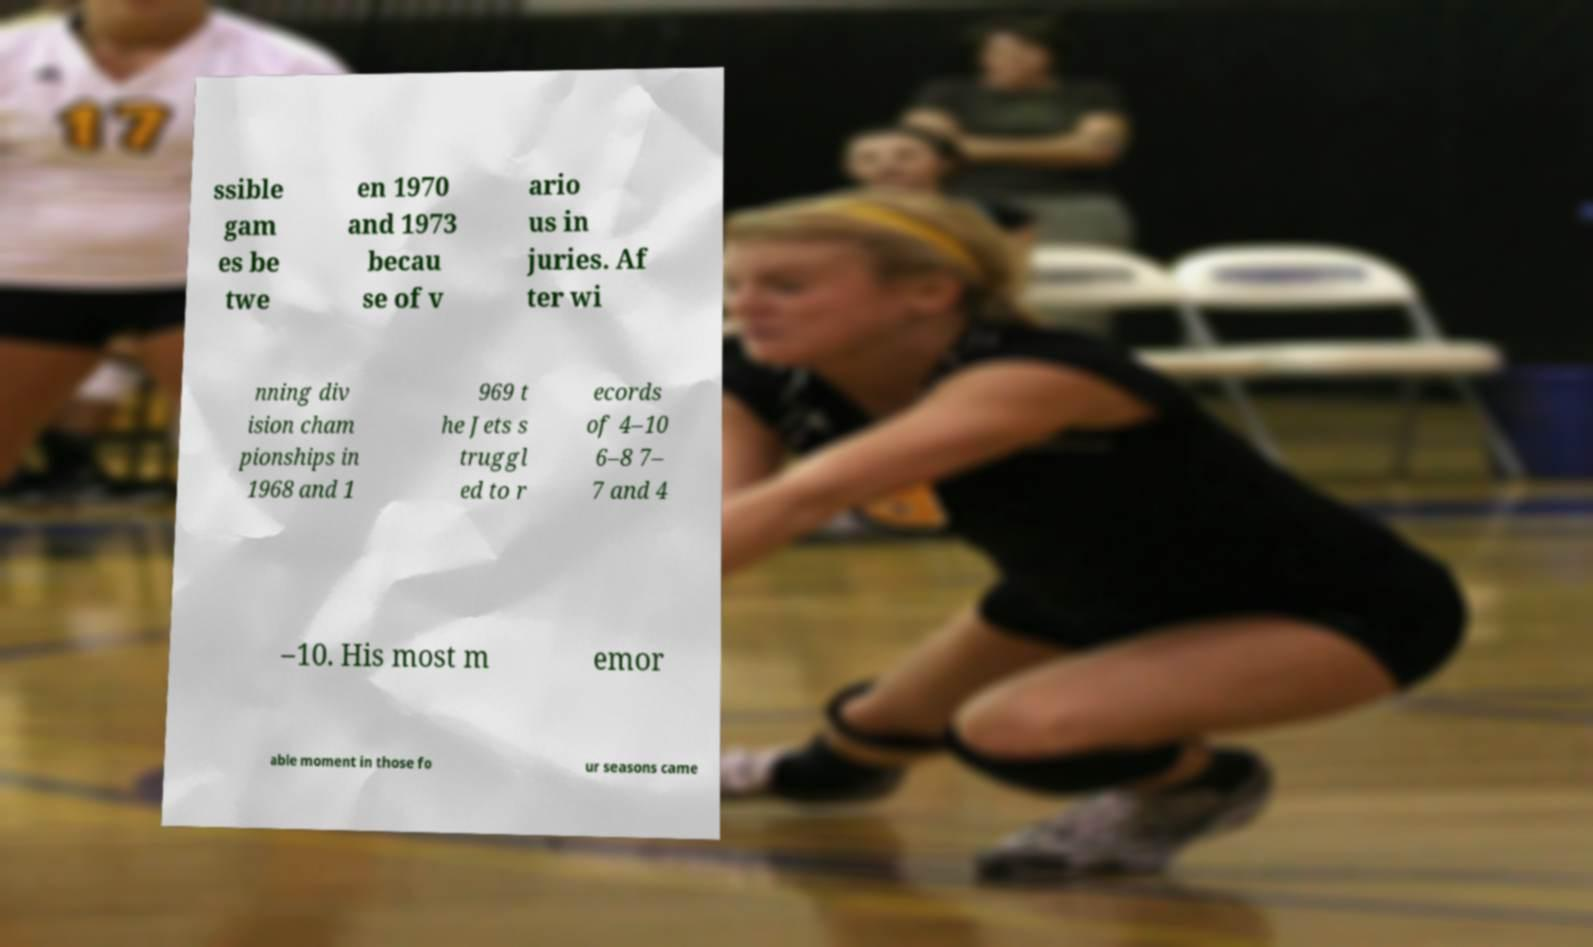I need the written content from this picture converted into text. Can you do that? ssible gam es be twe en 1970 and 1973 becau se of v ario us in juries. Af ter wi nning div ision cham pionships in 1968 and 1 969 t he Jets s truggl ed to r ecords of 4–10 6–8 7– 7 and 4 –10. His most m emor able moment in those fo ur seasons came 